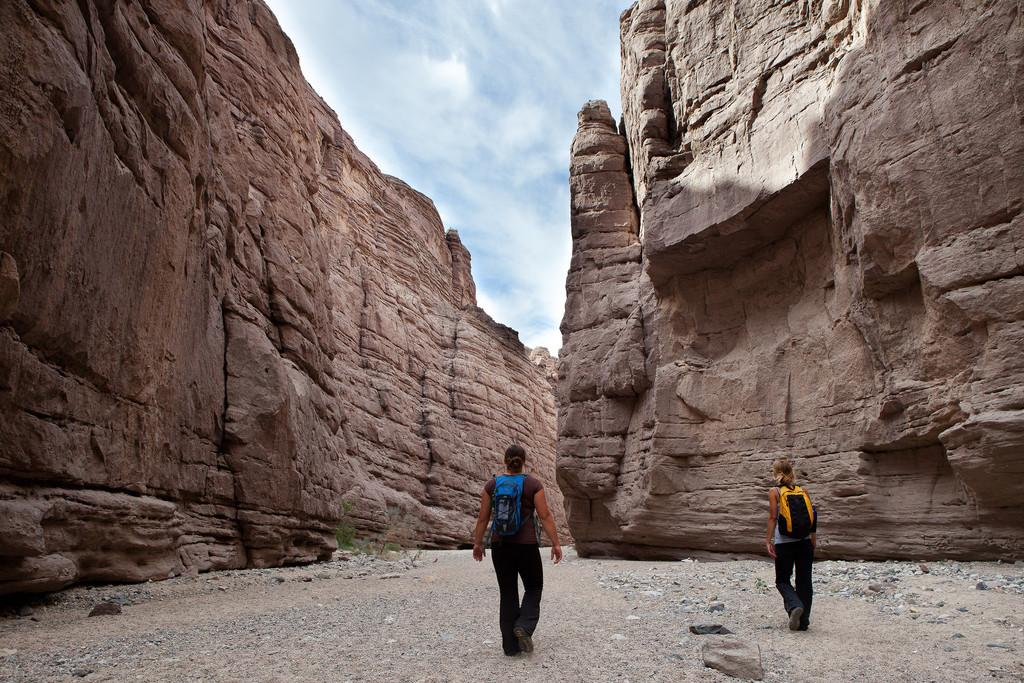What are the two women in the image doing? The two women are walking in the image. What is visible at the bottom of the image? There is ground visible at the bottom of the image. What can be seen in the background of the image? There are mountains and rocks in the background of the image. What is visible in the sky at the top of the image? There are clouds in the sky at the top of the image. What type of chain is being used by the women to climb the mountains in the image? There is no chain visible in the image, and the women are walking, not climbing. 